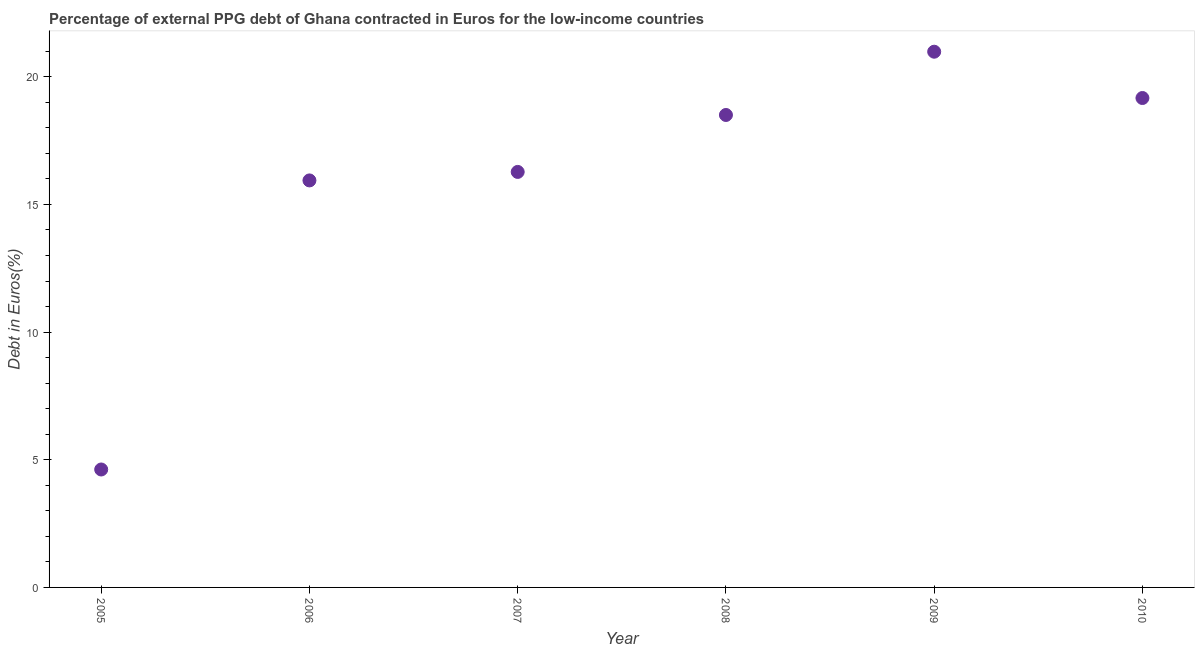What is the currency composition of ppg debt in 2006?
Make the answer very short. 15.94. Across all years, what is the maximum currency composition of ppg debt?
Ensure brevity in your answer.  20.98. Across all years, what is the minimum currency composition of ppg debt?
Provide a succinct answer. 4.62. In which year was the currency composition of ppg debt maximum?
Offer a terse response. 2009. In which year was the currency composition of ppg debt minimum?
Provide a short and direct response. 2005. What is the sum of the currency composition of ppg debt?
Ensure brevity in your answer.  95.48. What is the difference between the currency composition of ppg debt in 2007 and 2010?
Ensure brevity in your answer.  -2.89. What is the average currency composition of ppg debt per year?
Your answer should be very brief. 15.91. What is the median currency composition of ppg debt?
Your answer should be compact. 17.39. In how many years, is the currency composition of ppg debt greater than 2 %?
Your answer should be compact. 6. What is the ratio of the currency composition of ppg debt in 2007 to that in 2010?
Your response must be concise. 0.85. Is the currency composition of ppg debt in 2006 less than that in 2007?
Keep it short and to the point. Yes. What is the difference between the highest and the second highest currency composition of ppg debt?
Ensure brevity in your answer.  1.81. Is the sum of the currency composition of ppg debt in 2005 and 2010 greater than the maximum currency composition of ppg debt across all years?
Offer a terse response. Yes. What is the difference between the highest and the lowest currency composition of ppg debt?
Offer a terse response. 16.36. Does the currency composition of ppg debt monotonically increase over the years?
Your answer should be compact. No. How many years are there in the graph?
Ensure brevity in your answer.  6. Are the values on the major ticks of Y-axis written in scientific E-notation?
Provide a short and direct response. No. What is the title of the graph?
Ensure brevity in your answer.  Percentage of external PPG debt of Ghana contracted in Euros for the low-income countries. What is the label or title of the Y-axis?
Give a very brief answer. Debt in Euros(%). What is the Debt in Euros(%) in 2005?
Offer a terse response. 4.62. What is the Debt in Euros(%) in 2006?
Provide a short and direct response. 15.94. What is the Debt in Euros(%) in 2007?
Your response must be concise. 16.27. What is the Debt in Euros(%) in 2008?
Your answer should be very brief. 18.5. What is the Debt in Euros(%) in 2009?
Ensure brevity in your answer.  20.98. What is the Debt in Euros(%) in 2010?
Provide a succinct answer. 19.17. What is the difference between the Debt in Euros(%) in 2005 and 2006?
Your answer should be compact. -11.32. What is the difference between the Debt in Euros(%) in 2005 and 2007?
Give a very brief answer. -11.65. What is the difference between the Debt in Euros(%) in 2005 and 2008?
Your answer should be compact. -13.88. What is the difference between the Debt in Euros(%) in 2005 and 2009?
Keep it short and to the point. -16.36. What is the difference between the Debt in Euros(%) in 2005 and 2010?
Your answer should be very brief. -14.55. What is the difference between the Debt in Euros(%) in 2006 and 2007?
Keep it short and to the point. -0.33. What is the difference between the Debt in Euros(%) in 2006 and 2008?
Your response must be concise. -2.56. What is the difference between the Debt in Euros(%) in 2006 and 2009?
Keep it short and to the point. -5.04. What is the difference between the Debt in Euros(%) in 2006 and 2010?
Your response must be concise. -3.23. What is the difference between the Debt in Euros(%) in 2007 and 2008?
Offer a very short reply. -2.23. What is the difference between the Debt in Euros(%) in 2007 and 2009?
Your response must be concise. -4.71. What is the difference between the Debt in Euros(%) in 2007 and 2010?
Offer a very short reply. -2.89. What is the difference between the Debt in Euros(%) in 2008 and 2009?
Offer a terse response. -2.48. What is the difference between the Debt in Euros(%) in 2008 and 2010?
Ensure brevity in your answer.  -0.66. What is the difference between the Debt in Euros(%) in 2009 and 2010?
Your answer should be compact. 1.81. What is the ratio of the Debt in Euros(%) in 2005 to that in 2006?
Provide a short and direct response. 0.29. What is the ratio of the Debt in Euros(%) in 2005 to that in 2007?
Your response must be concise. 0.28. What is the ratio of the Debt in Euros(%) in 2005 to that in 2009?
Ensure brevity in your answer.  0.22. What is the ratio of the Debt in Euros(%) in 2005 to that in 2010?
Your answer should be very brief. 0.24. What is the ratio of the Debt in Euros(%) in 2006 to that in 2008?
Your answer should be very brief. 0.86. What is the ratio of the Debt in Euros(%) in 2006 to that in 2009?
Your answer should be very brief. 0.76. What is the ratio of the Debt in Euros(%) in 2006 to that in 2010?
Ensure brevity in your answer.  0.83. What is the ratio of the Debt in Euros(%) in 2007 to that in 2008?
Make the answer very short. 0.88. What is the ratio of the Debt in Euros(%) in 2007 to that in 2009?
Your answer should be compact. 0.78. What is the ratio of the Debt in Euros(%) in 2007 to that in 2010?
Make the answer very short. 0.85. What is the ratio of the Debt in Euros(%) in 2008 to that in 2009?
Provide a succinct answer. 0.88. What is the ratio of the Debt in Euros(%) in 2008 to that in 2010?
Provide a short and direct response. 0.96. What is the ratio of the Debt in Euros(%) in 2009 to that in 2010?
Make the answer very short. 1.09. 